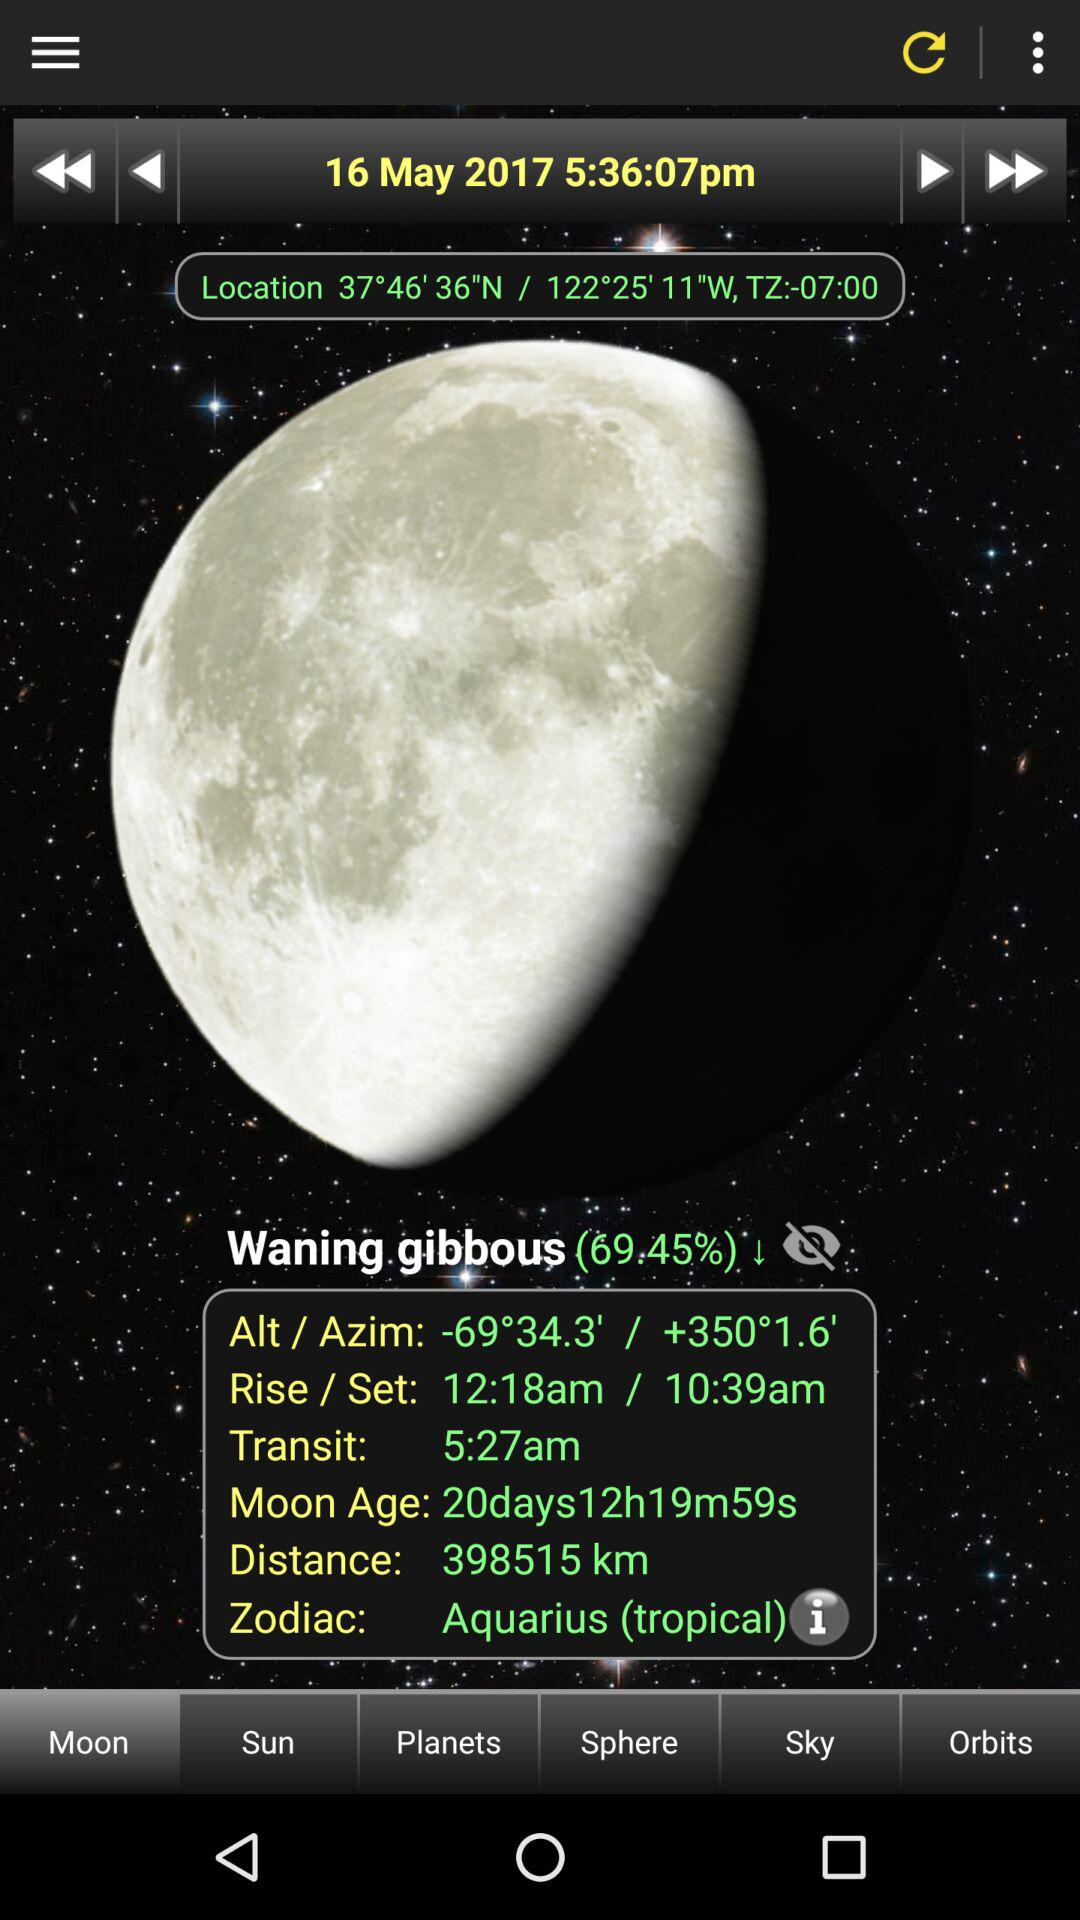What is the date? The date is May 16, 2017. 